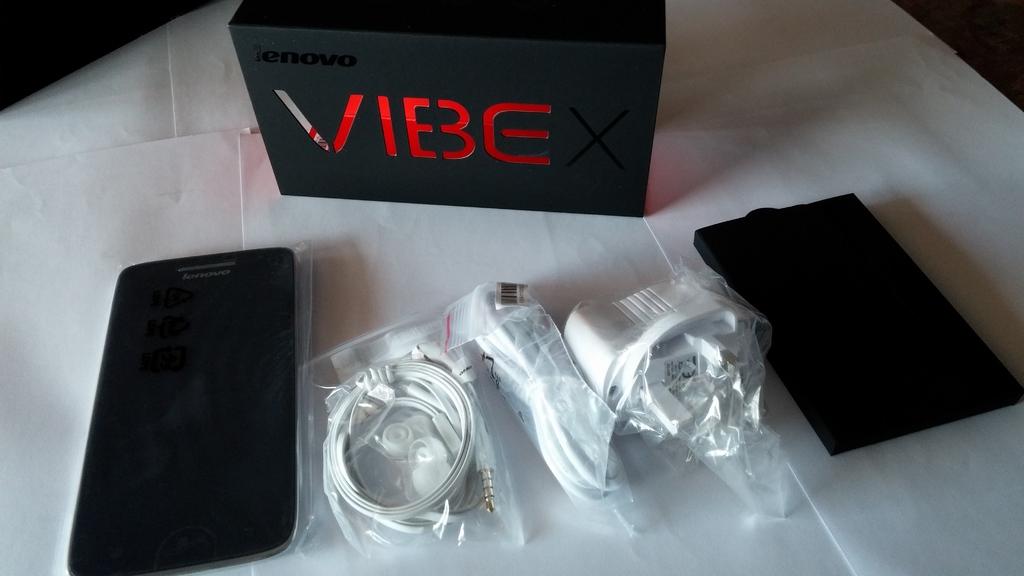What is the name of this phone?
Your answer should be compact. Vibe. Which company produced this phone?
Your response must be concise. Lenovo. 